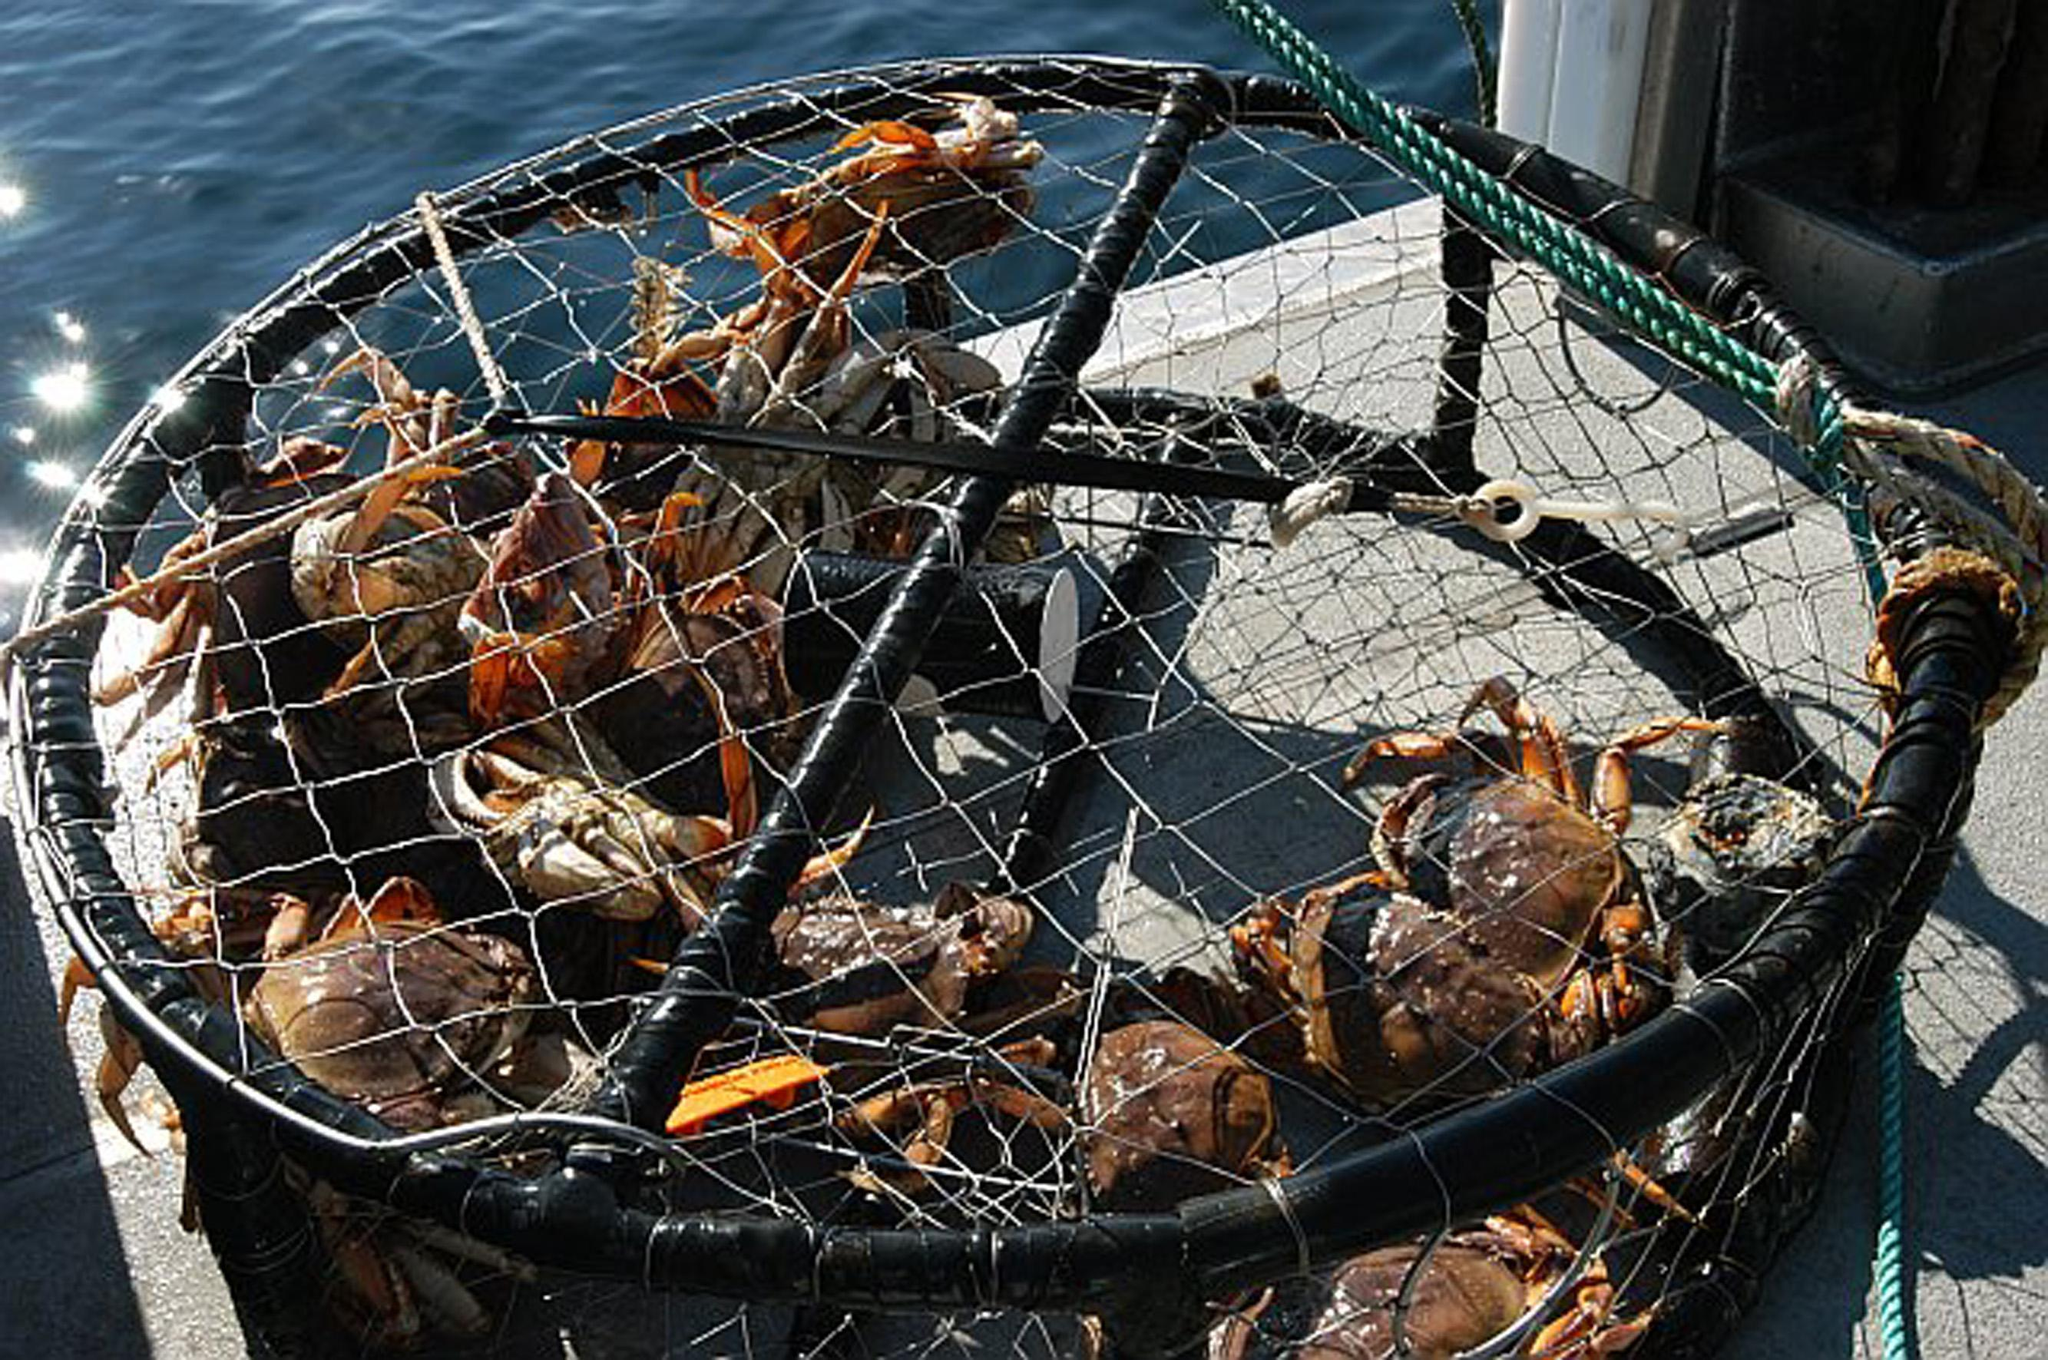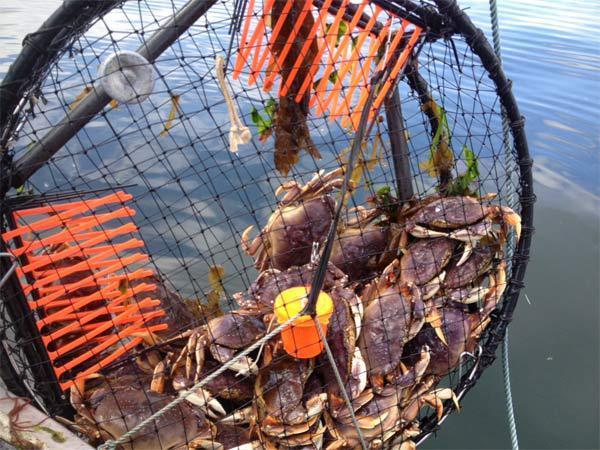The first image is the image on the left, the second image is the image on the right. Given the left and right images, does the statement "All of the baskets holding the crabs are circular." hold true? Answer yes or no. Yes. The first image is the image on the left, the second image is the image on the right. Evaluate the accuracy of this statement regarding the images: "All the crabs are in cages.". Is it true? Answer yes or no. Yes. 